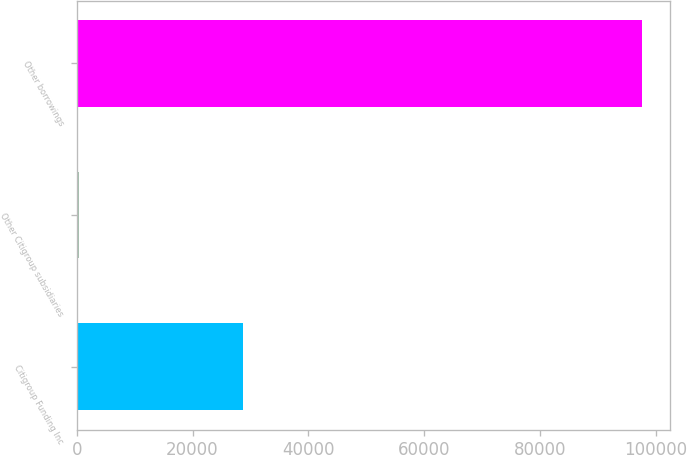<chart> <loc_0><loc_0><loc_500><loc_500><bar_chart><fcel>Citigroup Funding Inc<fcel>Other Citigroup subsidiaries<fcel>Other borrowings<nl><fcel>28654<fcel>471<fcel>97566<nl></chart> 